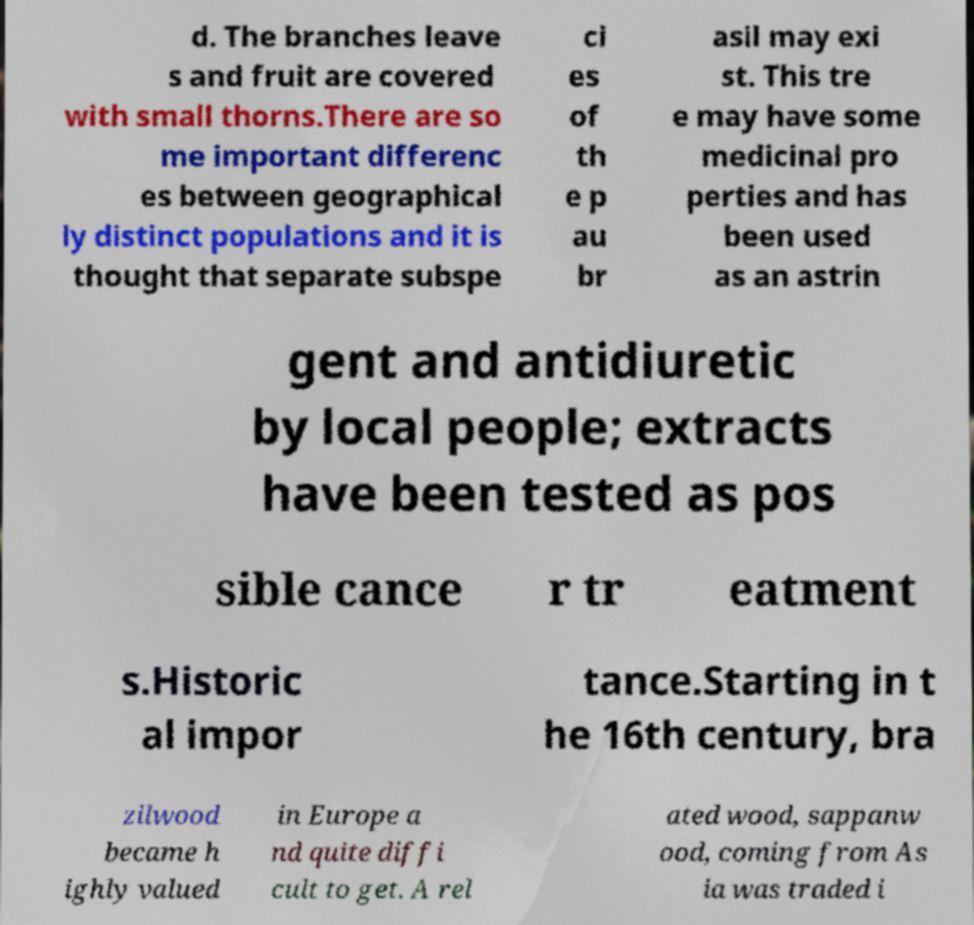Could you assist in decoding the text presented in this image and type it out clearly? d. The branches leave s and fruit are covered with small thorns.There are so me important differenc es between geographical ly distinct populations and it is thought that separate subspe ci es of th e p au br asil may exi st. This tre e may have some medicinal pro perties and has been used as an astrin gent and antidiuretic by local people; extracts have been tested as pos sible cance r tr eatment s.Historic al impor tance.Starting in t he 16th century, bra zilwood became h ighly valued in Europe a nd quite diffi cult to get. A rel ated wood, sappanw ood, coming from As ia was traded i 